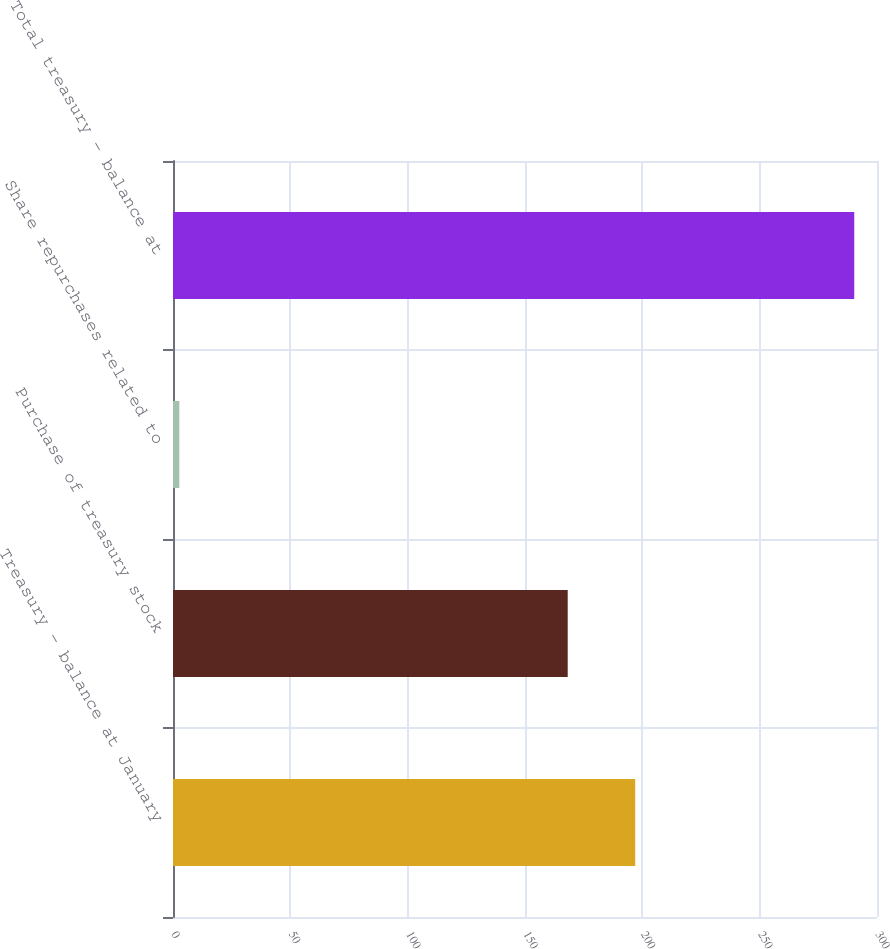Convert chart. <chart><loc_0><loc_0><loc_500><loc_500><bar_chart><fcel>Treasury - balance at January<fcel>Purchase of treasury stock<fcel>Share repurchases related to<fcel>Total treasury - balance at<nl><fcel>196.96<fcel>168.2<fcel>2.7<fcel>290.3<nl></chart> 